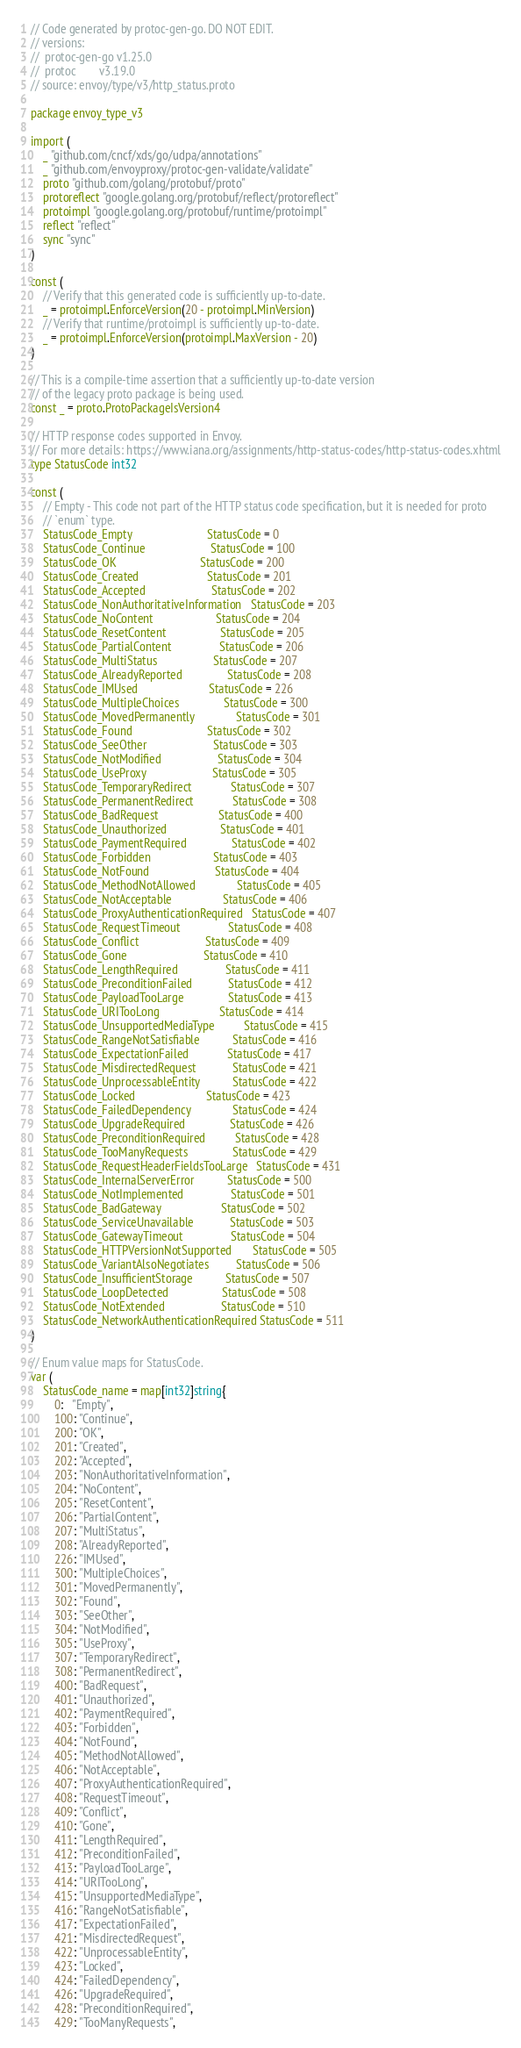<code> <loc_0><loc_0><loc_500><loc_500><_Go_>// Code generated by protoc-gen-go. DO NOT EDIT.
// versions:
// 	protoc-gen-go v1.25.0
// 	protoc        v3.19.0
// source: envoy/type/v3/http_status.proto

package envoy_type_v3

import (
	_ "github.com/cncf/xds/go/udpa/annotations"
	_ "github.com/envoyproxy/protoc-gen-validate/validate"
	proto "github.com/golang/protobuf/proto"
	protoreflect "google.golang.org/protobuf/reflect/protoreflect"
	protoimpl "google.golang.org/protobuf/runtime/protoimpl"
	reflect "reflect"
	sync "sync"
)

const (
	// Verify that this generated code is sufficiently up-to-date.
	_ = protoimpl.EnforceVersion(20 - protoimpl.MinVersion)
	// Verify that runtime/protoimpl is sufficiently up-to-date.
	_ = protoimpl.EnforceVersion(protoimpl.MaxVersion - 20)
)

// This is a compile-time assertion that a sufficiently up-to-date version
// of the legacy proto package is being used.
const _ = proto.ProtoPackageIsVersion4

// HTTP response codes supported in Envoy.
// For more details: https://www.iana.org/assignments/http-status-codes/http-status-codes.xhtml
type StatusCode int32

const (
	// Empty - This code not part of the HTTP status code specification, but it is needed for proto
	// `enum` type.
	StatusCode_Empty                         StatusCode = 0
	StatusCode_Continue                      StatusCode = 100
	StatusCode_OK                            StatusCode = 200
	StatusCode_Created                       StatusCode = 201
	StatusCode_Accepted                      StatusCode = 202
	StatusCode_NonAuthoritativeInformation   StatusCode = 203
	StatusCode_NoContent                     StatusCode = 204
	StatusCode_ResetContent                  StatusCode = 205
	StatusCode_PartialContent                StatusCode = 206
	StatusCode_MultiStatus                   StatusCode = 207
	StatusCode_AlreadyReported               StatusCode = 208
	StatusCode_IMUsed                        StatusCode = 226
	StatusCode_MultipleChoices               StatusCode = 300
	StatusCode_MovedPermanently              StatusCode = 301
	StatusCode_Found                         StatusCode = 302
	StatusCode_SeeOther                      StatusCode = 303
	StatusCode_NotModified                   StatusCode = 304
	StatusCode_UseProxy                      StatusCode = 305
	StatusCode_TemporaryRedirect             StatusCode = 307
	StatusCode_PermanentRedirect             StatusCode = 308
	StatusCode_BadRequest                    StatusCode = 400
	StatusCode_Unauthorized                  StatusCode = 401
	StatusCode_PaymentRequired               StatusCode = 402
	StatusCode_Forbidden                     StatusCode = 403
	StatusCode_NotFound                      StatusCode = 404
	StatusCode_MethodNotAllowed              StatusCode = 405
	StatusCode_NotAcceptable                 StatusCode = 406
	StatusCode_ProxyAuthenticationRequired   StatusCode = 407
	StatusCode_RequestTimeout                StatusCode = 408
	StatusCode_Conflict                      StatusCode = 409
	StatusCode_Gone                          StatusCode = 410
	StatusCode_LengthRequired                StatusCode = 411
	StatusCode_PreconditionFailed            StatusCode = 412
	StatusCode_PayloadTooLarge               StatusCode = 413
	StatusCode_URITooLong                    StatusCode = 414
	StatusCode_UnsupportedMediaType          StatusCode = 415
	StatusCode_RangeNotSatisfiable           StatusCode = 416
	StatusCode_ExpectationFailed             StatusCode = 417
	StatusCode_MisdirectedRequest            StatusCode = 421
	StatusCode_UnprocessableEntity           StatusCode = 422
	StatusCode_Locked                        StatusCode = 423
	StatusCode_FailedDependency              StatusCode = 424
	StatusCode_UpgradeRequired               StatusCode = 426
	StatusCode_PreconditionRequired          StatusCode = 428
	StatusCode_TooManyRequests               StatusCode = 429
	StatusCode_RequestHeaderFieldsTooLarge   StatusCode = 431
	StatusCode_InternalServerError           StatusCode = 500
	StatusCode_NotImplemented                StatusCode = 501
	StatusCode_BadGateway                    StatusCode = 502
	StatusCode_ServiceUnavailable            StatusCode = 503
	StatusCode_GatewayTimeout                StatusCode = 504
	StatusCode_HTTPVersionNotSupported       StatusCode = 505
	StatusCode_VariantAlsoNegotiates         StatusCode = 506
	StatusCode_InsufficientStorage           StatusCode = 507
	StatusCode_LoopDetected                  StatusCode = 508
	StatusCode_NotExtended                   StatusCode = 510
	StatusCode_NetworkAuthenticationRequired StatusCode = 511
)

// Enum value maps for StatusCode.
var (
	StatusCode_name = map[int32]string{
		0:   "Empty",
		100: "Continue",
		200: "OK",
		201: "Created",
		202: "Accepted",
		203: "NonAuthoritativeInformation",
		204: "NoContent",
		205: "ResetContent",
		206: "PartialContent",
		207: "MultiStatus",
		208: "AlreadyReported",
		226: "IMUsed",
		300: "MultipleChoices",
		301: "MovedPermanently",
		302: "Found",
		303: "SeeOther",
		304: "NotModified",
		305: "UseProxy",
		307: "TemporaryRedirect",
		308: "PermanentRedirect",
		400: "BadRequest",
		401: "Unauthorized",
		402: "PaymentRequired",
		403: "Forbidden",
		404: "NotFound",
		405: "MethodNotAllowed",
		406: "NotAcceptable",
		407: "ProxyAuthenticationRequired",
		408: "RequestTimeout",
		409: "Conflict",
		410: "Gone",
		411: "LengthRequired",
		412: "PreconditionFailed",
		413: "PayloadTooLarge",
		414: "URITooLong",
		415: "UnsupportedMediaType",
		416: "RangeNotSatisfiable",
		417: "ExpectationFailed",
		421: "MisdirectedRequest",
		422: "UnprocessableEntity",
		423: "Locked",
		424: "FailedDependency",
		426: "UpgradeRequired",
		428: "PreconditionRequired",
		429: "TooManyRequests",</code> 